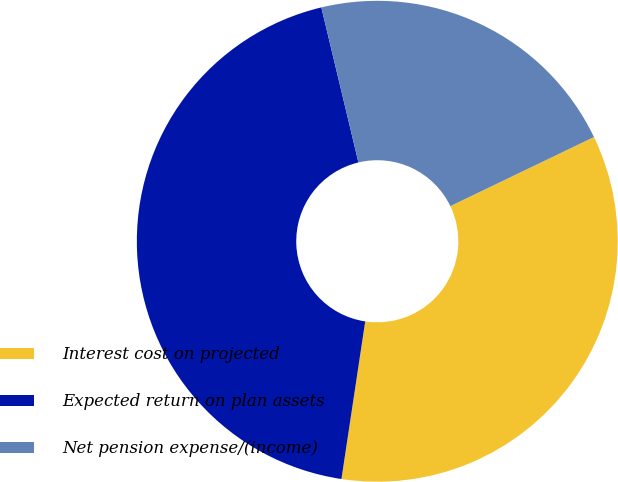Convert chart to OTSL. <chart><loc_0><loc_0><loc_500><loc_500><pie_chart><fcel>Interest cost on projected<fcel>Expected return on plan assets<fcel>Net pension expense/(income)<nl><fcel>34.52%<fcel>43.88%<fcel>21.6%<nl></chart> 